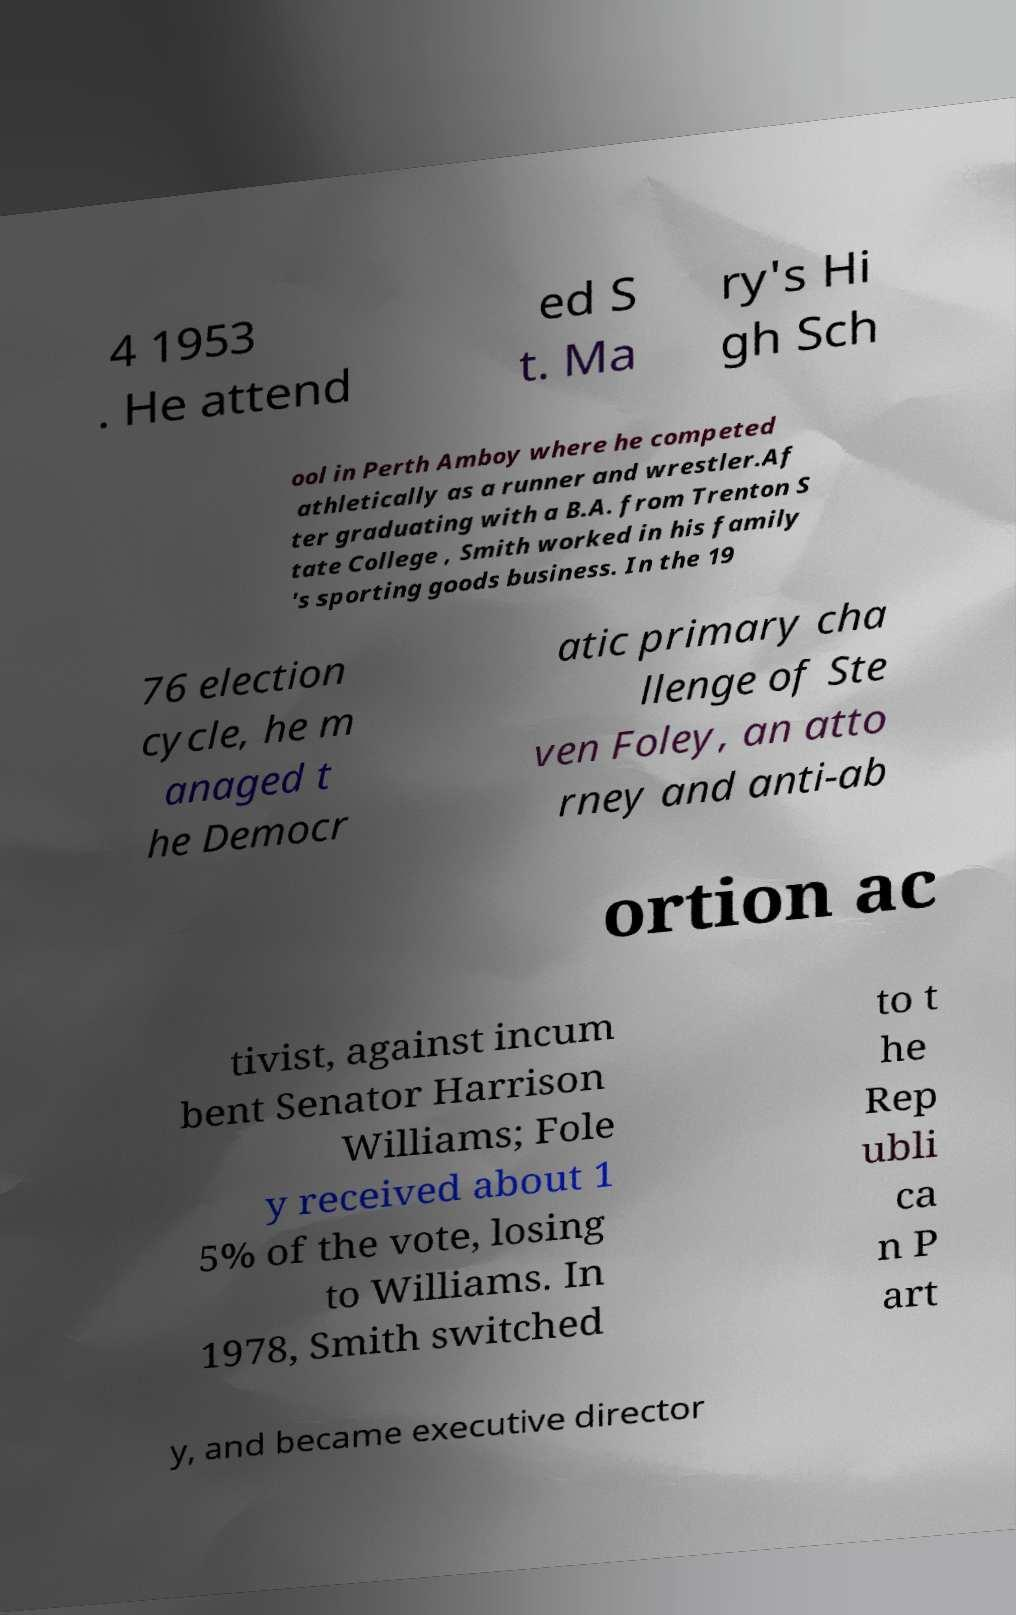What messages or text are displayed in this image? I need them in a readable, typed format. 4 1953 . He attend ed S t. Ma ry's Hi gh Sch ool in Perth Amboy where he competed athletically as a runner and wrestler.Af ter graduating with a B.A. from Trenton S tate College , Smith worked in his family 's sporting goods business. In the 19 76 election cycle, he m anaged t he Democr atic primary cha llenge of Ste ven Foley, an atto rney and anti-ab ortion ac tivist, against incum bent Senator Harrison Williams; Fole y received about 1 5% of the vote, losing to Williams. In 1978, Smith switched to t he Rep ubli ca n P art y, and became executive director 